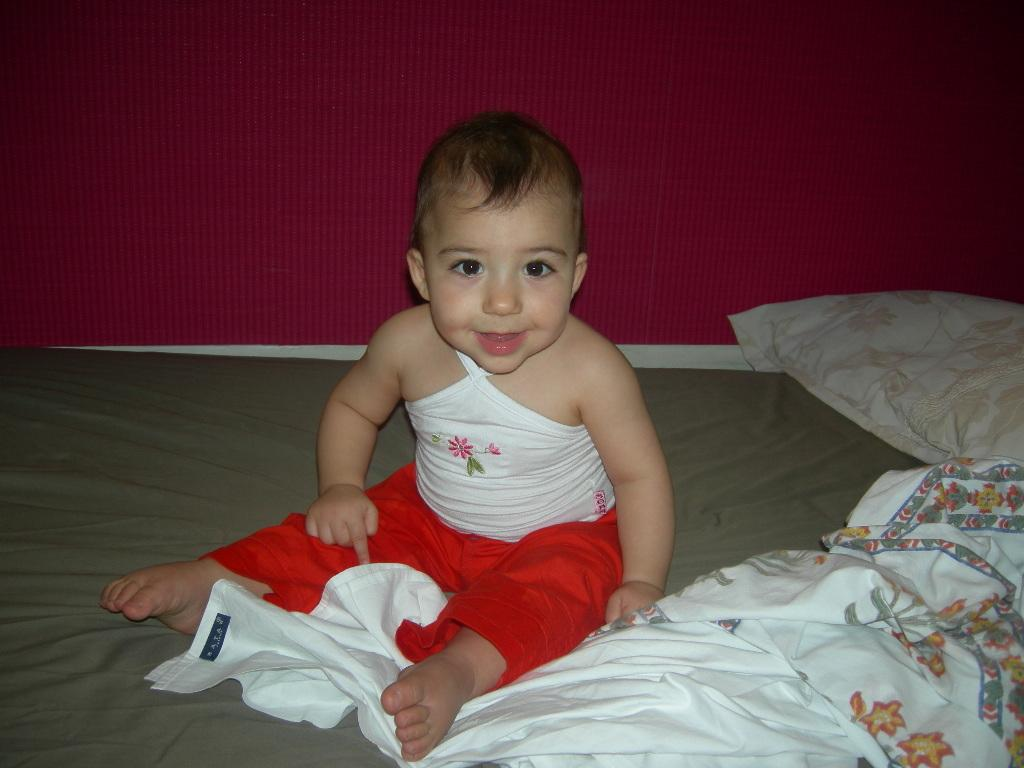What is the baby doing in the image? There is a baby sitting on the bed. What is present on the bed besides the baby? There is a pillow and a blanket on the bed. Can you tell me how the baby is turning the branch in the image? There is no branch present in the image; the baby is sitting on the bed with a pillow and a blanket. 